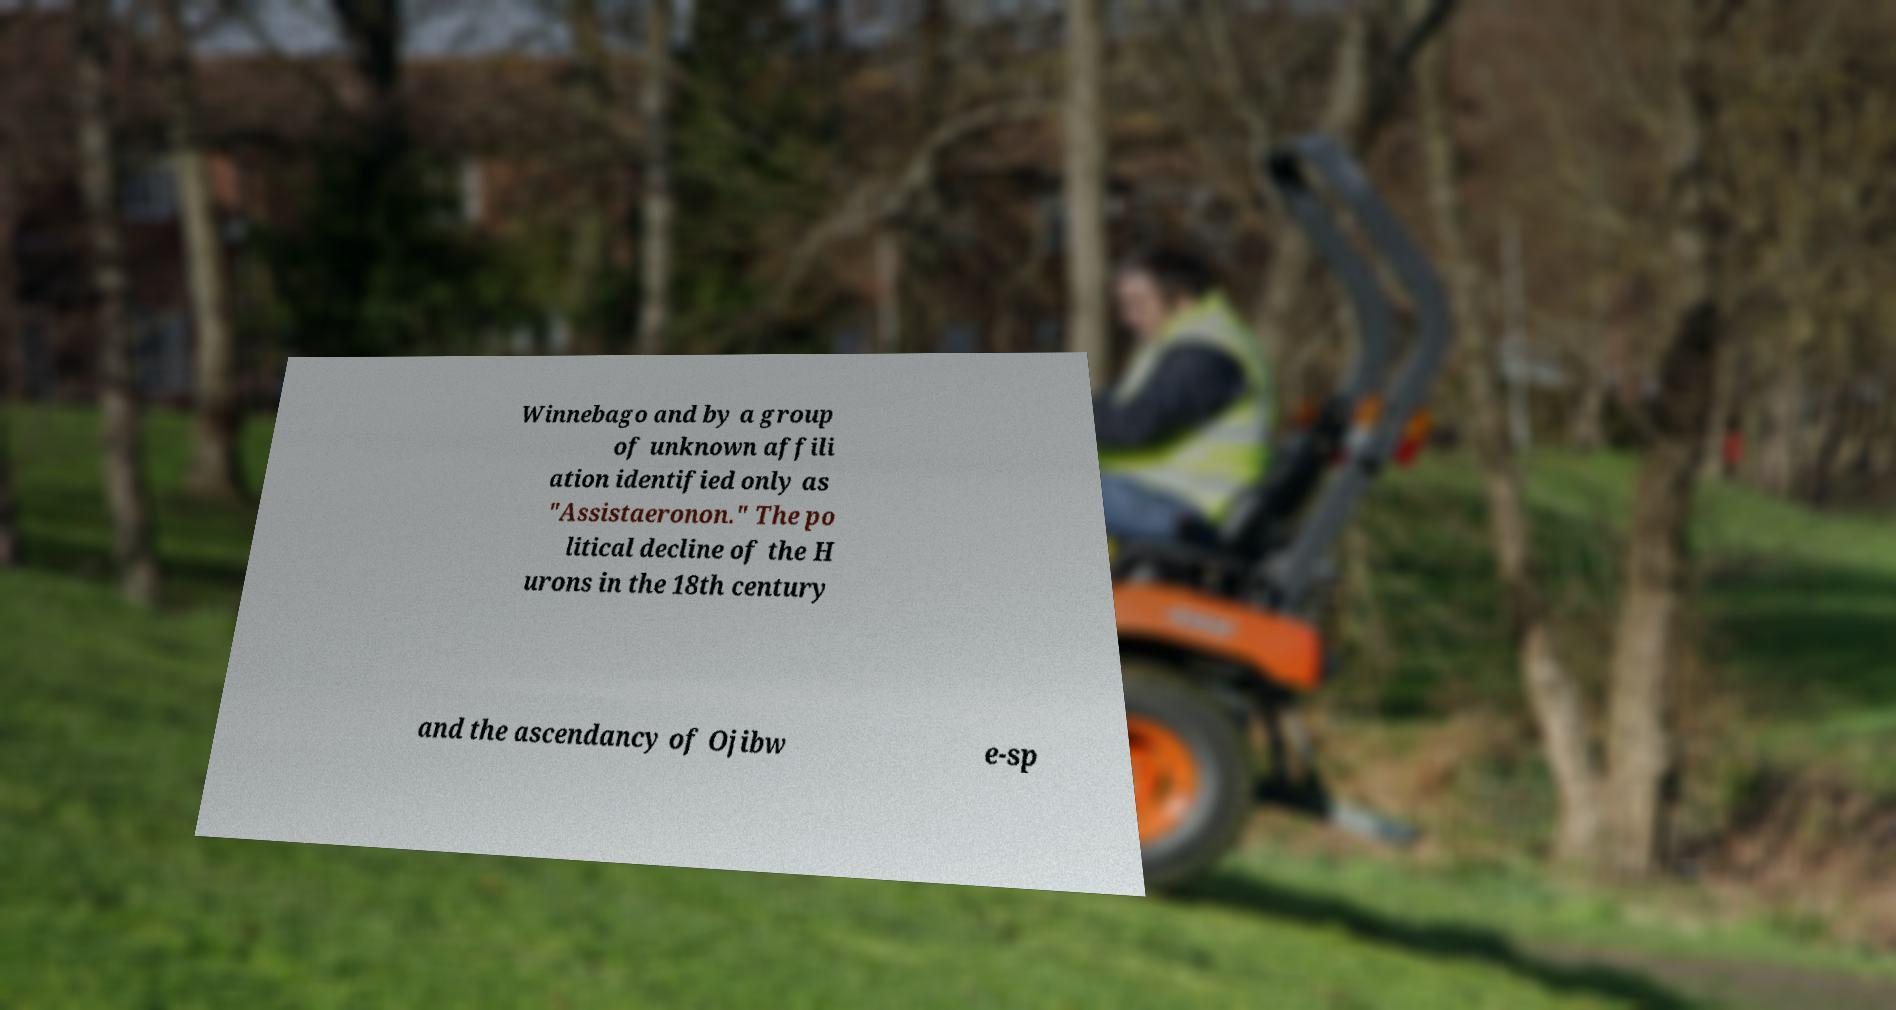Please read and relay the text visible in this image. What does it say? Winnebago and by a group of unknown affili ation identified only as "Assistaeronon." The po litical decline of the H urons in the 18th century and the ascendancy of Ojibw e-sp 